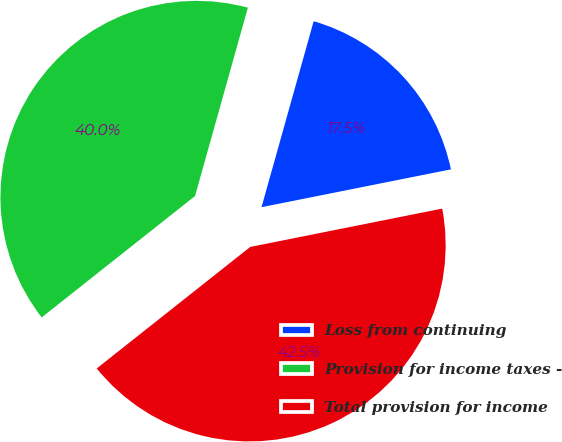Convert chart to OTSL. <chart><loc_0><loc_0><loc_500><loc_500><pie_chart><fcel>Loss from continuing<fcel>Provision for income taxes -<fcel>Total provision for income<nl><fcel>17.51%<fcel>40.01%<fcel>42.48%<nl></chart> 